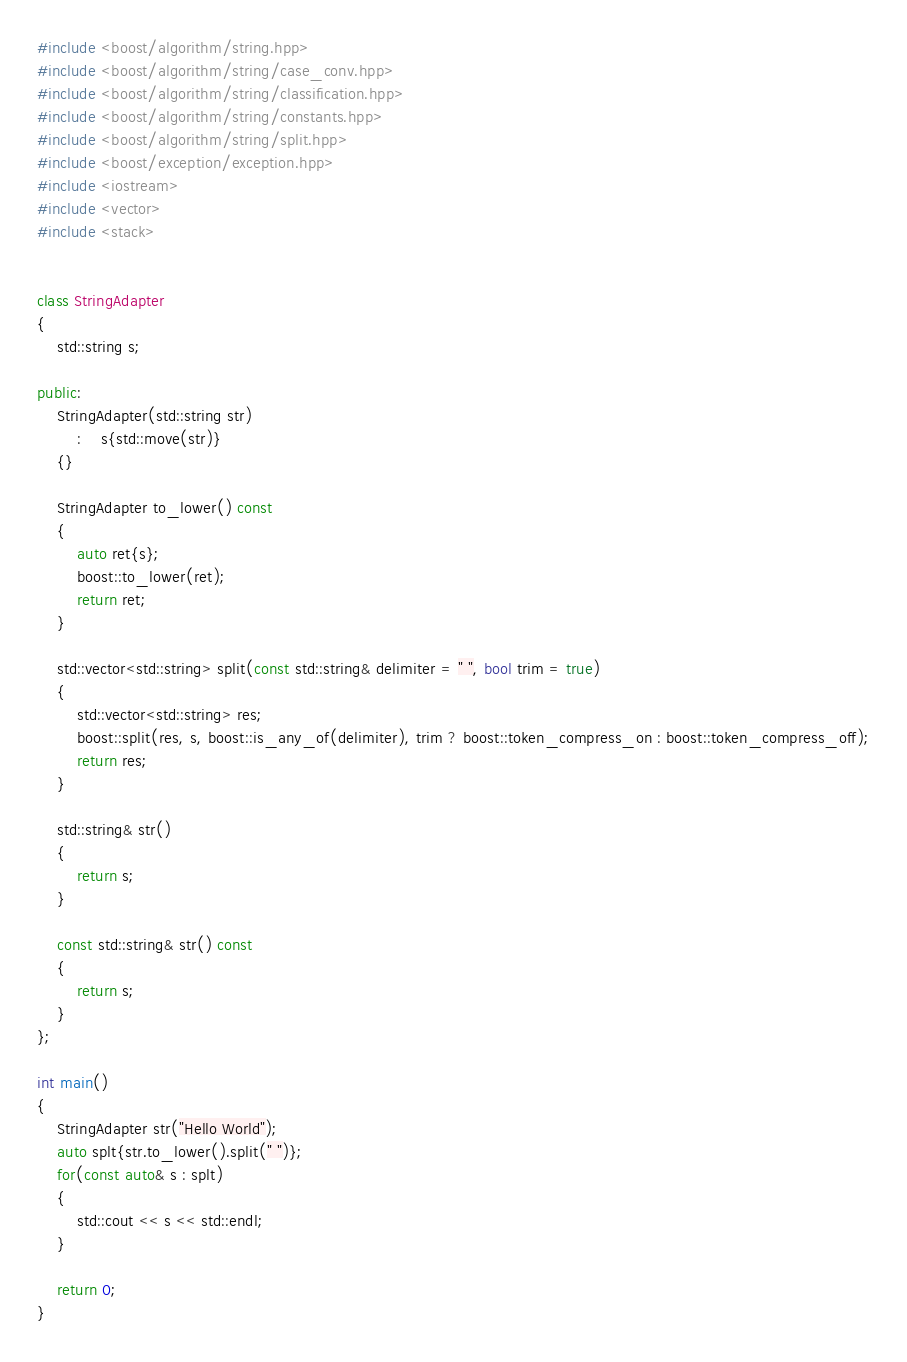<code> <loc_0><loc_0><loc_500><loc_500><_C++_>#include <boost/algorithm/string.hpp>
#include <boost/algorithm/string/case_conv.hpp>
#include <boost/algorithm/string/classification.hpp>
#include <boost/algorithm/string/constants.hpp>
#include <boost/algorithm/string/split.hpp>
#include <boost/exception/exception.hpp>
#include <iostream>
#include <vector>
#include <stack>


class StringAdapter
{
	std::string s;

public:
	StringAdapter(std::string str)
		:	s{std::move(str)}
	{}

	StringAdapter to_lower() const
	{
		auto ret{s};
		boost::to_lower(ret);
		return ret;
	}

	std::vector<std::string> split(const std::string& delimiter = " ", bool trim = true)
	{
		std::vector<std::string> res;
		boost::split(res, s, boost::is_any_of(delimiter), trim ? boost::token_compress_on : boost::token_compress_off);
		return res;
	}

	std::string& str()
	{
		return s;
	}

	const std::string& str() const
	{
		return s;
	}
};

int main()
{
	StringAdapter str("Hello World");
	auto splt{str.to_lower().split(" ")};
	for(const auto& s : splt)
	{
		std::cout << s << std::endl;
	}

	return 0;
}

</code> 